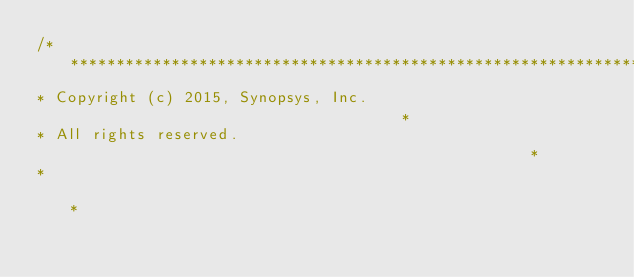Convert code to text. <code><loc_0><loc_0><loc_500><loc_500><_C_>/*************************************************************************
* Copyright (c) 2015, Synopsys, Inc.                                     *
* All rights reserved.                                                   *
*                                                                        *</code> 